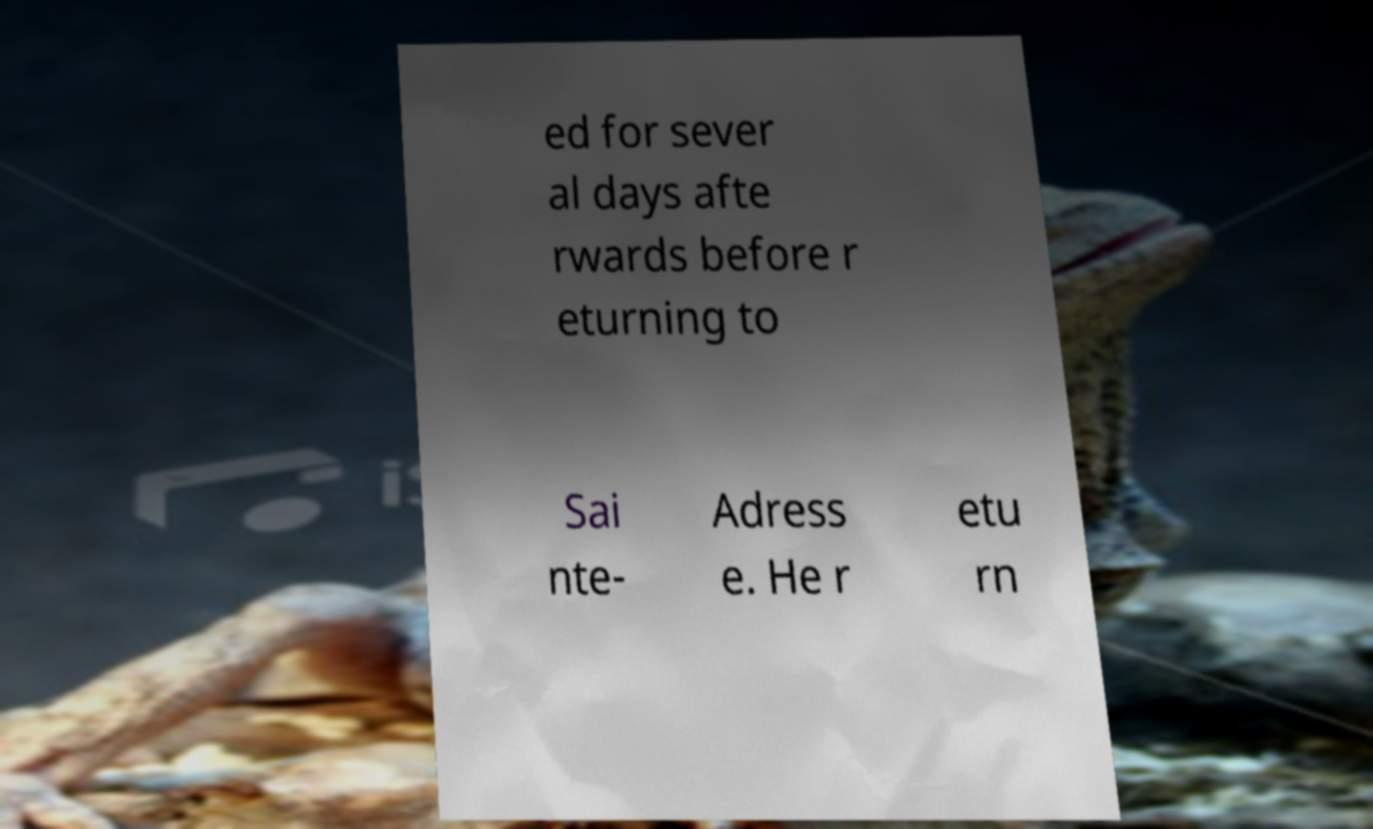What messages or text are displayed in this image? I need them in a readable, typed format. ed for sever al days afte rwards before r eturning to Sai nte- Adress e. He r etu rn 